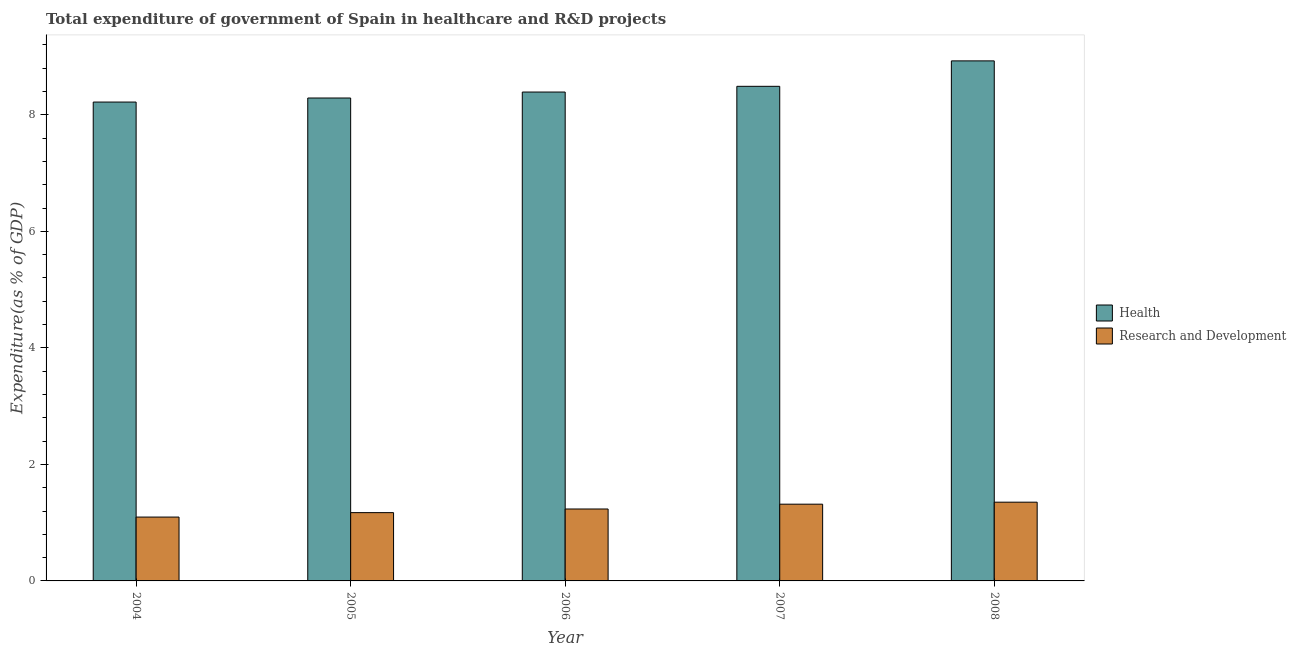How many groups of bars are there?
Keep it short and to the point. 5. Are the number of bars per tick equal to the number of legend labels?
Your answer should be very brief. Yes. How many bars are there on the 2nd tick from the left?
Offer a terse response. 2. How many bars are there on the 3rd tick from the right?
Offer a very short reply. 2. What is the label of the 5th group of bars from the left?
Keep it short and to the point. 2008. In how many cases, is the number of bars for a given year not equal to the number of legend labels?
Your answer should be very brief. 0. What is the expenditure in healthcare in 2008?
Your answer should be compact. 8.93. Across all years, what is the maximum expenditure in r&d?
Provide a short and direct response. 1.35. Across all years, what is the minimum expenditure in r&d?
Make the answer very short. 1.1. In which year was the expenditure in r&d maximum?
Your answer should be compact. 2008. What is the total expenditure in r&d in the graph?
Your answer should be very brief. 6.17. What is the difference between the expenditure in r&d in 2006 and that in 2008?
Make the answer very short. -0.12. What is the difference between the expenditure in healthcare in 2005 and the expenditure in r&d in 2008?
Your response must be concise. -0.64. What is the average expenditure in healthcare per year?
Offer a terse response. 8.46. In the year 2004, what is the difference between the expenditure in healthcare and expenditure in r&d?
Your answer should be very brief. 0. What is the ratio of the expenditure in r&d in 2006 to that in 2007?
Keep it short and to the point. 0.94. Is the difference between the expenditure in r&d in 2005 and 2008 greater than the difference between the expenditure in healthcare in 2005 and 2008?
Provide a succinct answer. No. What is the difference between the highest and the second highest expenditure in healthcare?
Give a very brief answer. 0.44. What is the difference between the highest and the lowest expenditure in r&d?
Give a very brief answer. 0.26. What does the 2nd bar from the left in 2007 represents?
Give a very brief answer. Research and Development. What does the 2nd bar from the right in 2008 represents?
Your answer should be very brief. Health. How many bars are there?
Your answer should be compact. 10. Are all the bars in the graph horizontal?
Your answer should be compact. No. How many years are there in the graph?
Make the answer very short. 5. What is the difference between two consecutive major ticks on the Y-axis?
Provide a short and direct response. 2. Does the graph contain any zero values?
Your answer should be compact. No. How are the legend labels stacked?
Make the answer very short. Vertical. What is the title of the graph?
Keep it short and to the point. Total expenditure of government of Spain in healthcare and R&D projects. What is the label or title of the X-axis?
Make the answer very short. Year. What is the label or title of the Y-axis?
Provide a succinct answer. Expenditure(as % of GDP). What is the Expenditure(as % of GDP) of Health in 2004?
Provide a succinct answer. 8.22. What is the Expenditure(as % of GDP) in Research and Development in 2004?
Ensure brevity in your answer.  1.1. What is the Expenditure(as % of GDP) of Health in 2005?
Offer a terse response. 8.29. What is the Expenditure(as % of GDP) of Research and Development in 2005?
Give a very brief answer. 1.17. What is the Expenditure(as % of GDP) in Health in 2006?
Provide a succinct answer. 8.39. What is the Expenditure(as % of GDP) in Research and Development in 2006?
Offer a very short reply. 1.23. What is the Expenditure(as % of GDP) in Health in 2007?
Ensure brevity in your answer.  8.49. What is the Expenditure(as % of GDP) of Research and Development in 2007?
Keep it short and to the point. 1.32. What is the Expenditure(as % of GDP) of Health in 2008?
Your answer should be very brief. 8.93. What is the Expenditure(as % of GDP) in Research and Development in 2008?
Keep it short and to the point. 1.35. Across all years, what is the maximum Expenditure(as % of GDP) of Health?
Keep it short and to the point. 8.93. Across all years, what is the maximum Expenditure(as % of GDP) of Research and Development?
Offer a very short reply. 1.35. Across all years, what is the minimum Expenditure(as % of GDP) of Health?
Keep it short and to the point. 8.22. Across all years, what is the minimum Expenditure(as % of GDP) in Research and Development?
Your answer should be very brief. 1.1. What is the total Expenditure(as % of GDP) of Health in the graph?
Offer a terse response. 42.31. What is the total Expenditure(as % of GDP) in Research and Development in the graph?
Your answer should be compact. 6.17. What is the difference between the Expenditure(as % of GDP) of Health in 2004 and that in 2005?
Offer a very short reply. -0.07. What is the difference between the Expenditure(as % of GDP) of Research and Development in 2004 and that in 2005?
Provide a succinct answer. -0.08. What is the difference between the Expenditure(as % of GDP) in Health in 2004 and that in 2006?
Make the answer very short. -0.17. What is the difference between the Expenditure(as % of GDP) in Research and Development in 2004 and that in 2006?
Offer a terse response. -0.14. What is the difference between the Expenditure(as % of GDP) of Health in 2004 and that in 2007?
Give a very brief answer. -0.27. What is the difference between the Expenditure(as % of GDP) in Research and Development in 2004 and that in 2007?
Make the answer very short. -0.22. What is the difference between the Expenditure(as % of GDP) in Health in 2004 and that in 2008?
Ensure brevity in your answer.  -0.71. What is the difference between the Expenditure(as % of GDP) in Research and Development in 2004 and that in 2008?
Your answer should be compact. -0.26. What is the difference between the Expenditure(as % of GDP) in Health in 2005 and that in 2006?
Ensure brevity in your answer.  -0.1. What is the difference between the Expenditure(as % of GDP) of Research and Development in 2005 and that in 2006?
Your answer should be compact. -0.06. What is the difference between the Expenditure(as % of GDP) of Health in 2005 and that in 2007?
Your response must be concise. -0.2. What is the difference between the Expenditure(as % of GDP) of Research and Development in 2005 and that in 2007?
Ensure brevity in your answer.  -0.14. What is the difference between the Expenditure(as % of GDP) in Health in 2005 and that in 2008?
Your answer should be very brief. -0.64. What is the difference between the Expenditure(as % of GDP) of Research and Development in 2005 and that in 2008?
Provide a short and direct response. -0.18. What is the difference between the Expenditure(as % of GDP) in Health in 2006 and that in 2007?
Your response must be concise. -0.1. What is the difference between the Expenditure(as % of GDP) in Research and Development in 2006 and that in 2007?
Offer a very short reply. -0.08. What is the difference between the Expenditure(as % of GDP) in Health in 2006 and that in 2008?
Offer a terse response. -0.54. What is the difference between the Expenditure(as % of GDP) in Research and Development in 2006 and that in 2008?
Make the answer very short. -0.12. What is the difference between the Expenditure(as % of GDP) of Health in 2007 and that in 2008?
Make the answer very short. -0.44. What is the difference between the Expenditure(as % of GDP) in Research and Development in 2007 and that in 2008?
Your answer should be very brief. -0.03. What is the difference between the Expenditure(as % of GDP) in Health in 2004 and the Expenditure(as % of GDP) in Research and Development in 2005?
Offer a very short reply. 7.05. What is the difference between the Expenditure(as % of GDP) of Health in 2004 and the Expenditure(as % of GDP) of Research and Development in 2006?
Keep it short and to the point. 6.98. What is the difference between the Expenditure(as % of GDP) in Health in 2004 and the Expenditure(as % of GDP) in Research and Development in 2007?
Offer a very short reply. 6.9. What is the difference between the Expenditure(as % of GDP) of Health in 2004 and the Expenditure(as % of GDP) of Research and Development in 2008?
Offer a very short reply. 6.87. What is the difference between the Expenditure(as % of GDP) of Health in 2005 and the Expenditure(as % of GDP) of Research and Development in 2006?
Make the answer very short. 7.05. What is the difference between the Expenditure(as % of GDP) of Health in 2005 and the Expenditure(as % of GDP) of Research and Development in 2007?
Your answer should be compact. 6.97. What is the difference between the Expenditure(as % of GDP) in Health in 2005 and the Expenditure(as % of GDP) in Research and Development in 2008?
Provide a short and direct response. 6.94. What is the difference between the Expenditure(as % of GDP) in Health in 2006 and the Expenditure(as % of GDP) in Research and Development in 2007?
Your answer should be compact. 7.07. What is the difference between the Expenditure(as % of GDP) of Health in 2006 and the Expenditure(as % of GDP) of Research and Development in 2008?
Provide a succinct answer. 7.04. What is the difference between the Expenditure(as % of GDP) of Health in 2007 and the Expenditure(as % of GDP) of Research and Development in 2008?
Provide a short and direct response. 7.14. What is the average Expenditure(as % of GDP) of Health per year?
Provide a succinct answer. 8.46. What is the average Expenditure(as % of GDP) of Research and Development per year?
Offer a very short reply. 1.23. In the year 2004, what is the difference between the Expenditure(as % of GDP) of Health and Expenditure(as % of GDP) of Research and Development?
Ensure brevity in your answer.  7.12. In the year 2005, what is the difference between the Expenditure(as % of GDP) in Health and Expenditure(as % of GDP) in Research and Development?
Your answer should be compact. 7.12. In the year 2006, what is the difference between the Expenditure(as % of GDP) in Health and Expenditure(as % of GDP) in Research and Development?
Make the answer very short. 7.16. In the year 2007, what is the difference between the Expenditure(as % of GDP) in Health and Expenditure(as % of GDP) in Research and Development?
Make the answer very short. 7.17. In the year 2008, what is the difference between the Expenditure(as % of GDP) in Health and Expenditure(as % of GDP) in Research and Development?
Keep it short and to the point. 7.57. What is the ratio of the Expenditure(as % of GDP) in Research and Development in 2004 to that in 2005?
Offer a terse response. 0.93. What is the ratio of the Expenditure(as % of GDP) of Health in 2004 to that in 2006?
Your response must be concise. 0.98. What is the ratio of the Expenditure(as % of GDP) in Research and Development in 2004 to that in 2006?
Your answer should be very brief. 0.89. What is the ratio of the Expenditure(as % of GDP) of Health in 2004 to that in 2007?
Your answer should be very brief. 0.97. What is the ratio of the Expenditure(as % of GDP) in Research and Development in 2004 to that in 2007?
Offer a terse response. 0.83. What is the ratio of the Expenditure(as % of GDP) of Health in 2004 to that in 2008?
Offer a terse response. 0.92. What is the ratio of the Expenditure(as % of GDP) in Research and Development in 2004 to that in 2008?
Give a very brief answer. 0.81. What is the ratio of the Expenditure(as % of GDP) in Research and Development in 2005 to that in 2006?
Give a very brief answer. 0.95. What is the ratio of the Expenditure(as % of GDP) in Health in 2005 to that in 2007?
Your answer should be very brief. 0.98. What is the ratio of the Expenditure(as % of GDP) in Research and Development in 2005 to that in 2007?
Provide a succinct answer. 0.89. What is the ratio of the Expenditure(as % of GDP) in Health in 2005 to that in 2008?
Provide a short and direct response. 0.93. What is the ratio of the Expenditure(as % of GDP) of Research and Development in 2005 to that in 2008?
Provide a short and direct response. 0.87. What is the ratio of the Expenditure(as % of GDP) in Health in 2006 to that in 2007?
Offer a terse response. 0.99. What is the ratio of the Expenditure(as % of GDP) of Research and Development in 2006 to that in 2007?
Keep it short and to the point. 0.94. What is the ratio of the Expenditure(as % of GDP) of Health in 2006 to that in 2008?
Offer a very short reply. 0.94. What is the ratio of the Expenditure(as % of GDP) of Research and Development in 2006 to that in 2008?
Your answer should be very brief. 0.91. What is the ratio of the Expenditure(as % of GDP) in Health in 2007 to that in 2008?
Ensure brevity in your answer.  0.95. What is the ratio of the Expenditure(as % of GDP) in Research and Development in 2007 to that in 2008?
Make the answer very short. 0.97. What is the difference between the highest and the second highest Expenditure(as % of GDP) in Health?
Provide a succinct answer. 0.44. What is the difference between the highest and the second highest Expenditure(as % of GDP) in Research and Development?
Make the answer very short. 0.03. What is the difference between the highest and the lowest Expenditure(as % of GDP) of Health?
Your response must be concise. 0.71. What is the difference between the highest and the lowest Expenditure(as % of GDP) in Research and Development?
Make the answer very short. 0.26. 